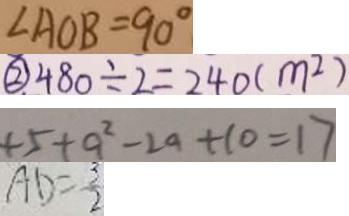<formula> <loc_0><loc_0><loc_500><loc_500>\angle A O B = 9 0 ^ { \circ } 
 \textcircled { 2 } 4 8 0 \div 2 = 2 4 0 ( m ^ { 2 } ) 
 + 5 + a ^ { 2 } - 2 a + 1 0 = 1 7 
 A D = \frac { 3 } { 2 }</formula> 